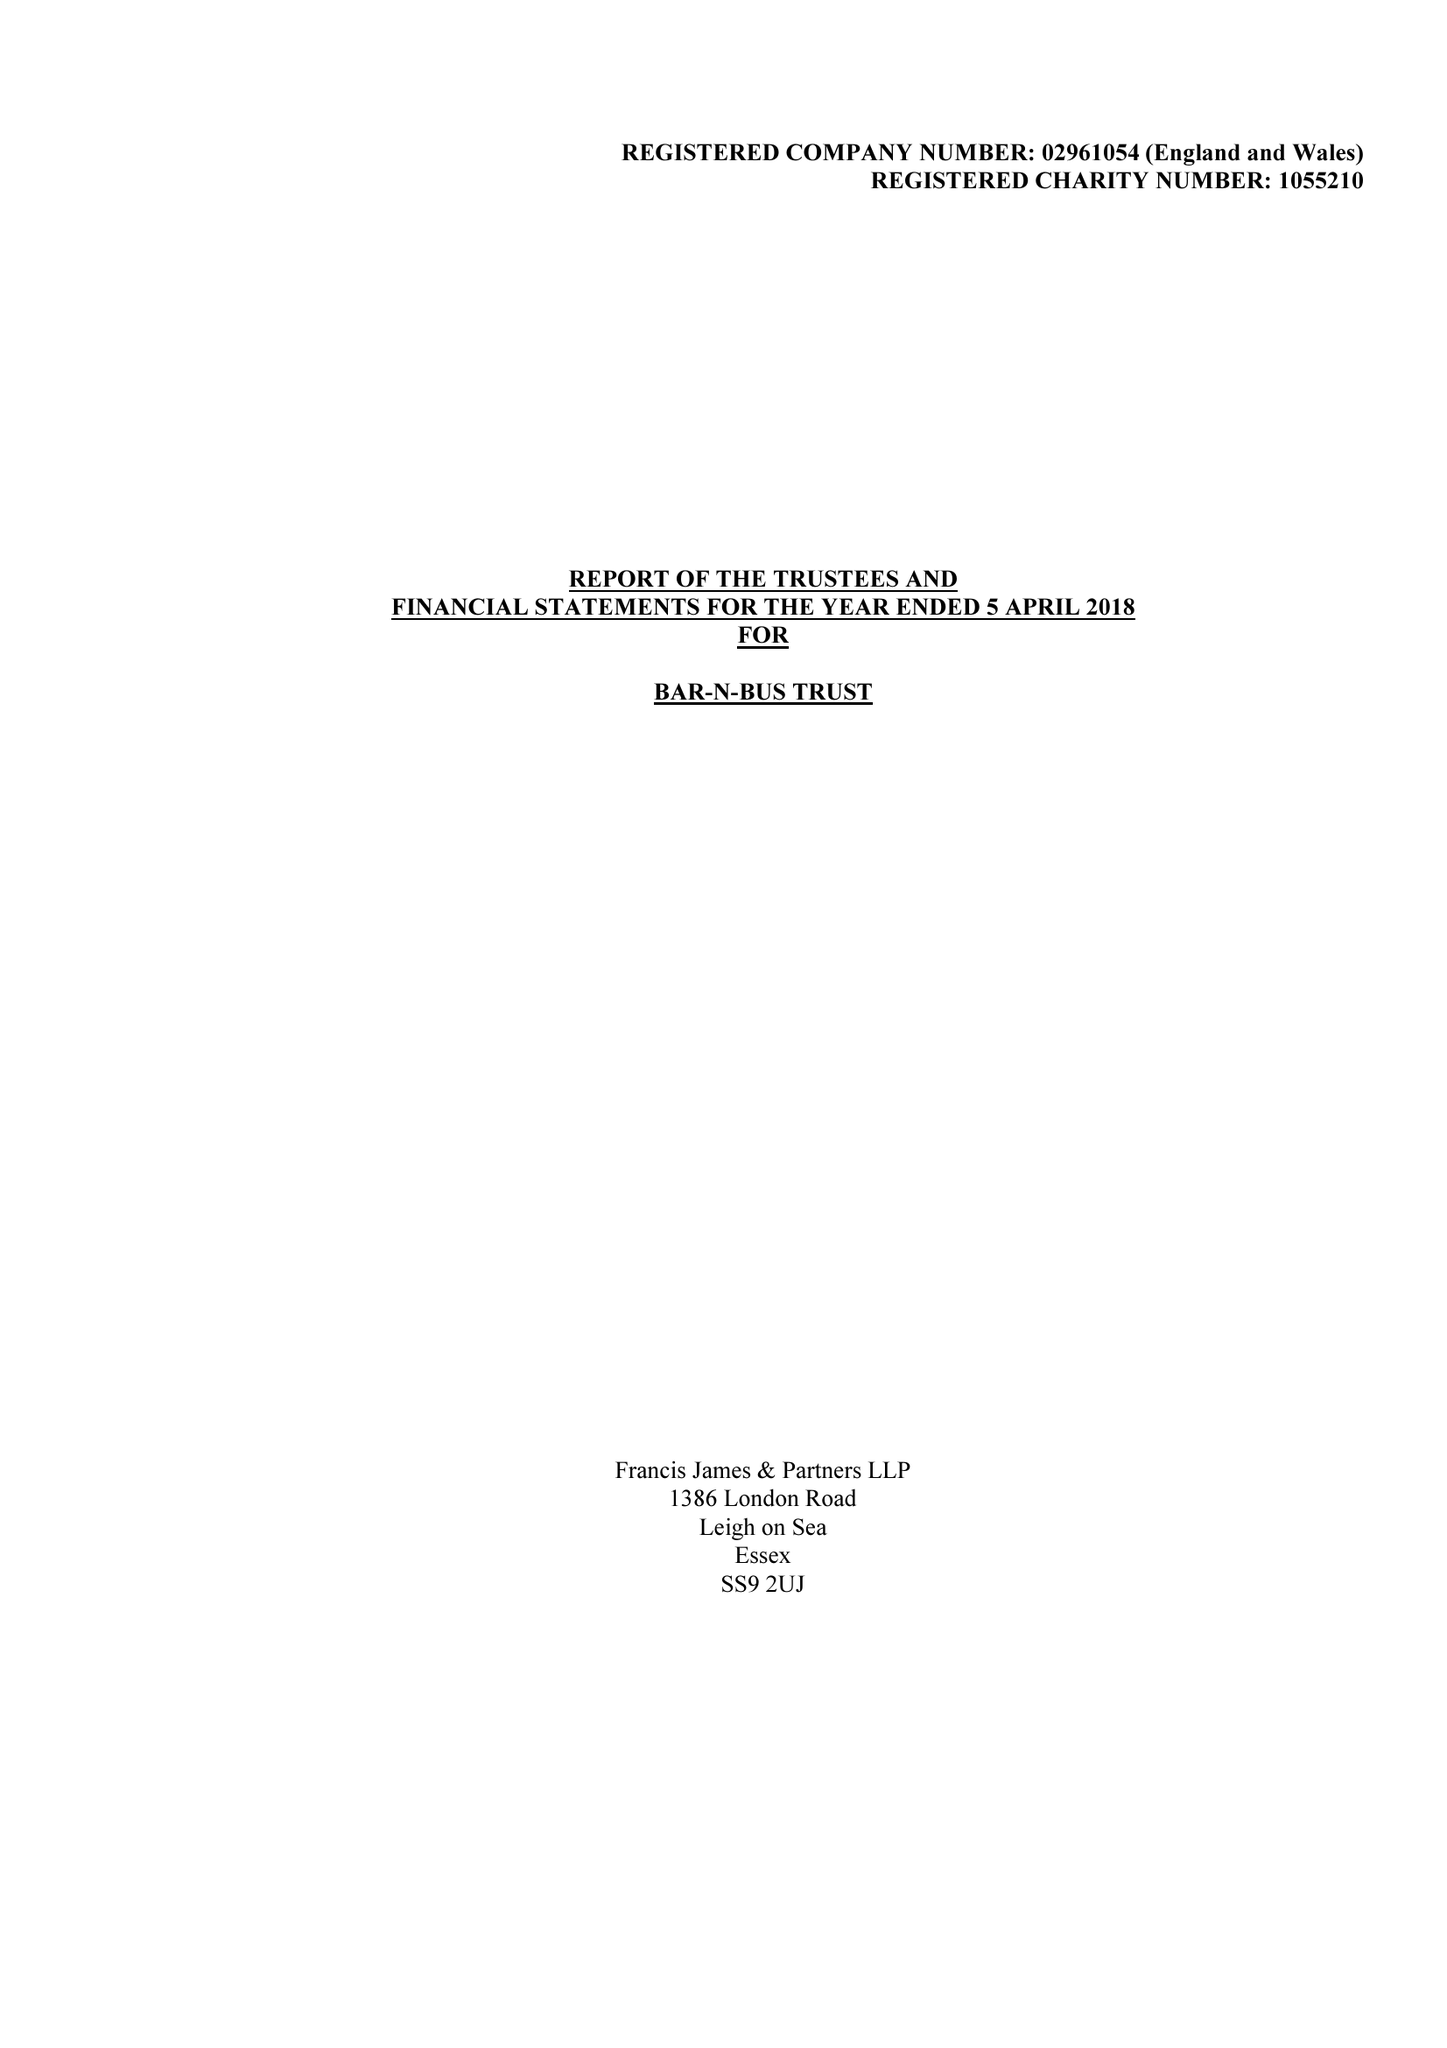What is the value for the address__postcode?
Answer the question using a single word or phrase. SS0 0AU 